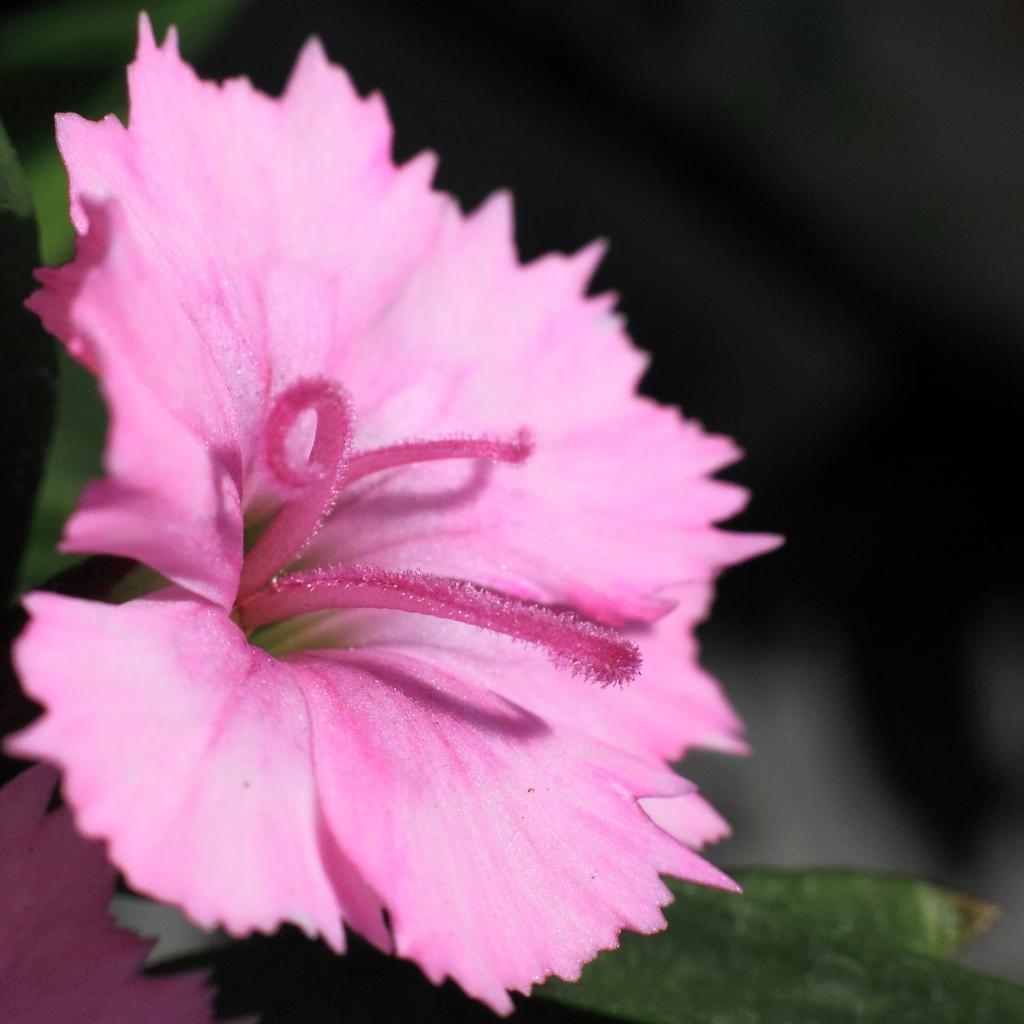In one or two sentences, can you explain what this image depicts? In this image we can see a flower which is in pink color. 